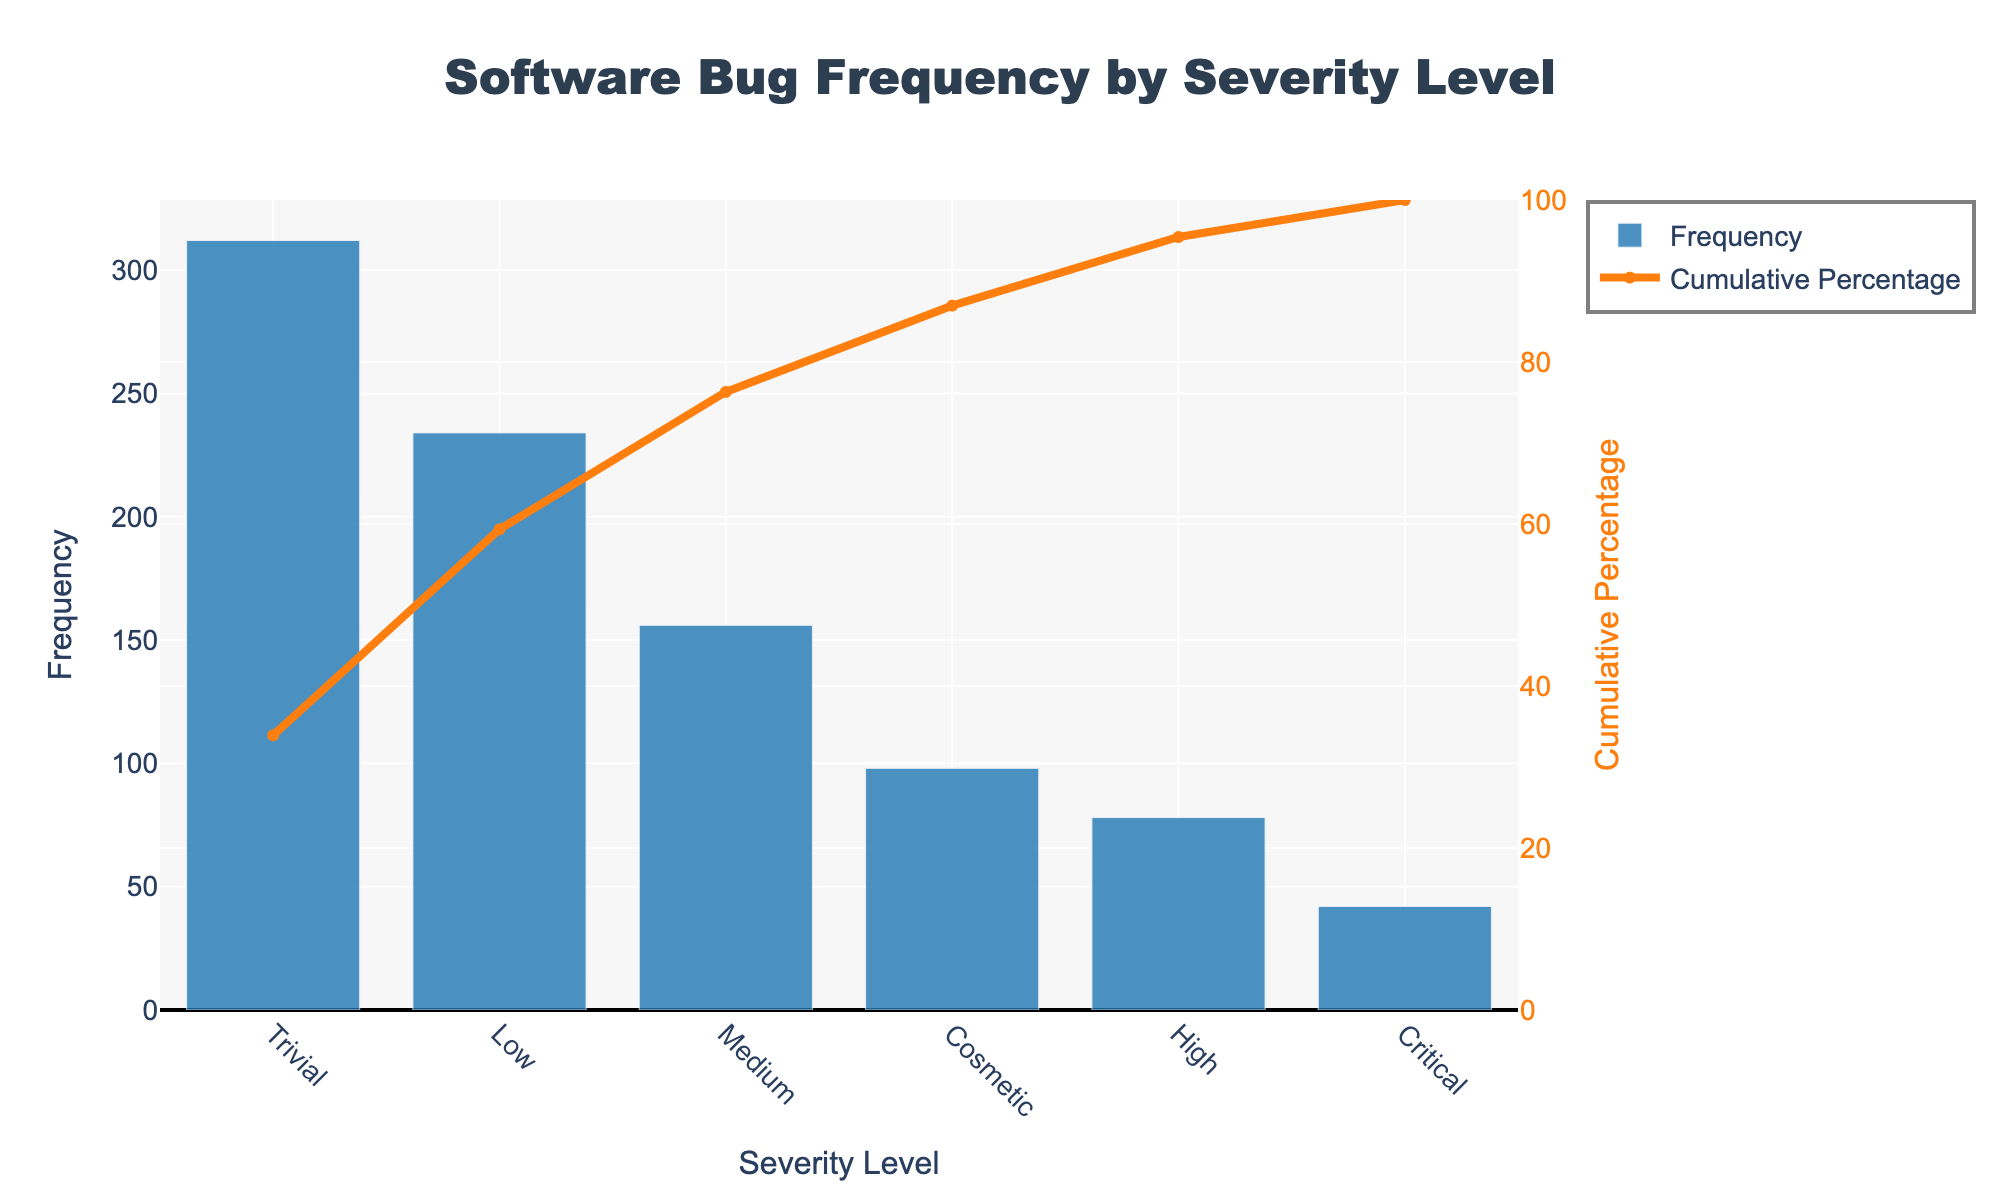What is the title of the chart? The title of the chart is at the top center and reads "Software Bug Frequency by Severity Level".
Answer: Software Bug Frequency by Severity Level Which severity level has the highest frequency of bugs? The severity with the highest frequency is where the bar is tallest. The "Trivial" severity has the tallest bar.
Answer: Trivial How many bugs are classified as "Critical"? Read the value of the "Critical" bar from the y-axis. The "Critical" severity shows 42 bugs.
Answer: 42 Which severity level has the lowest frequency of bugs? The severity with the lowest frequency is where the bar is shortest. The "Critical" severity has the shortest bar.
Answer: Critical What is the cumulative percentage for "High" severity bugs? Follow the line for "High" severity and read the corresponding right y-axis value. The line intersects "High" at approximately 31%.
Answer: 31% How many bug severity levels are displayed on the chart? Count the number of bars or x-axis categories representing severity levels. There are 6 severity levels displayed.
Answer: 6 Compare the frequency of "High" and "Cosmetic" severity bugs. Which one is higher? Compare the height of the bars for "High" and "Cosmetic". The "High" severity bar is higher, indicating a higher frequency.
Answer: High What percentage of bugs are of "Medium" severity? Read the cumulative percentage line for "Medium" and subtract the cumulative percentage of the previous severity. "Medium" cumulative is about 46%, subtract "High" cumulative which is about 31%, gives 15%.
Answer: 15% Is the cumulative percentage for the first three severity levels shown greater than 80%? Add the cumulative percentages of the first three severity levels. "Trivial" (42%) + "Low" (71%) + "Medium" (46%) is 42% + 29% + 15% = 86%.
Answer: Yes What is the combined frequency of "Critical" and "Cosmetic" severity bugs? Add the frequencies of "Critical" and "Cosmetic". "Critical" has 42 bugs and "Cosmetic" has 98 bugs. 42 + 98 = 140.
Answer: 140 